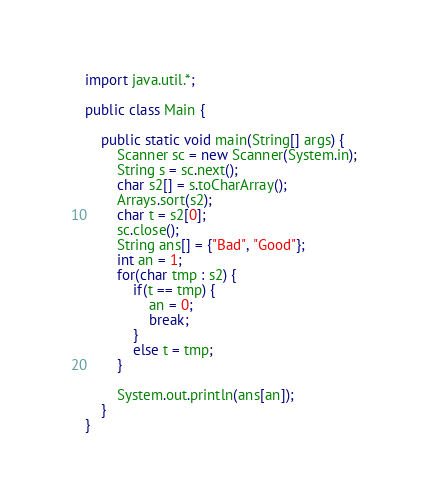Convert code to text. <code><loc_0><loc_0><loc_500><loc_500><_Java_>import java.util.*;

public class Main {
	
	public static void main(String[] args) {
		Scanner sc = new Scanner(System.in);
		String s = sc.next();
		char s2[] = s.toCharArray();
		Arrays.sort(s2);
		char t = s2[0];
		sc.close();
		String ans[] = {"Bad", "Good"};
		int an = 1;
		for(char tmp : s2) {
			if(t == tmp) {
				an = 0;
				break;
			}
			else t = tmp;
		}
		
		System.out.println(ans[an]);
	}
}
</code> 